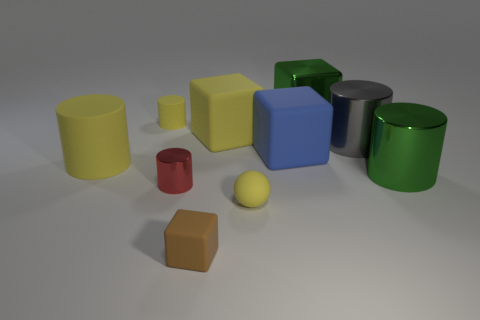Subtract all large yellow cylinders. How many cylinders are left? 4 Subtract 1 spheres. How many spheres are left? 0 Subtract all blocks. How many objects are left? 6 Subtract all blue blocks. How many blocks are left? 3 Subtract all purple cylinders. Subtract all rubber balls. How many objects are left? 9 Add 8 blue matte blocks. How many blue matte blocks are left? 9 Add 6 small brown cubes. How many small brown cubes exist? 7 Subtract 1 green cylinders. How many objects are left? 9 Subtract all yellow cylinders. Subtract all brown spheres. How many cylinders are left? 3 Subtract all green balls. How many blue blocks are left? 1 